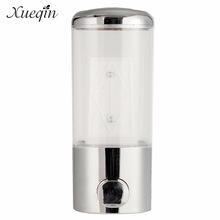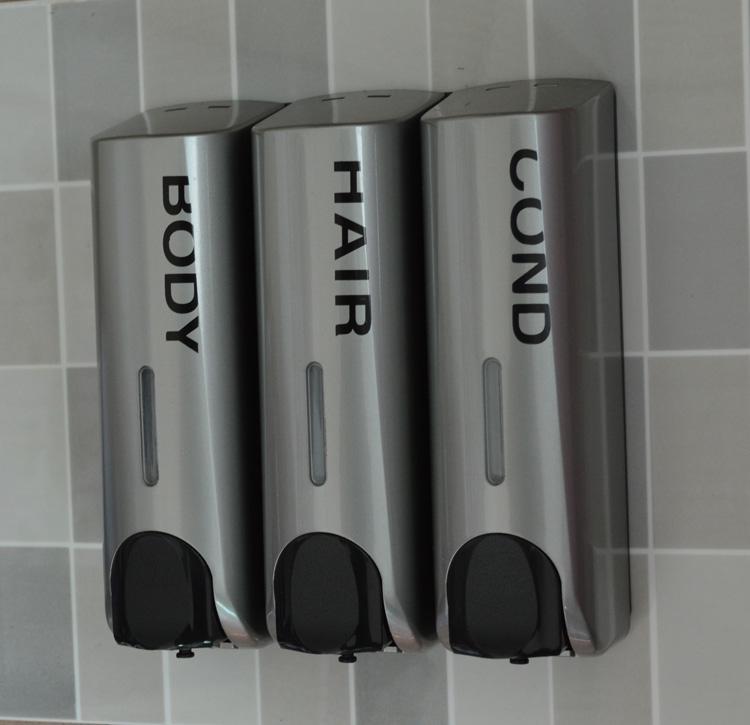The first image is the image on the left, the second image is the image on the right. Examine the images to the left and right. Is the description "One of the dispensers is brown and silver." accurate? Answer yes or no. No. 